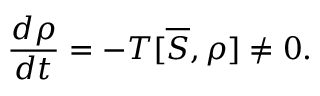Convert formula to latex. <formula><loc_0><loc_0><loc_500><loc_500>\frac { d \rho } { d t } = - T [ \overline { S } , \rho ] \neq 0 .</formula> 